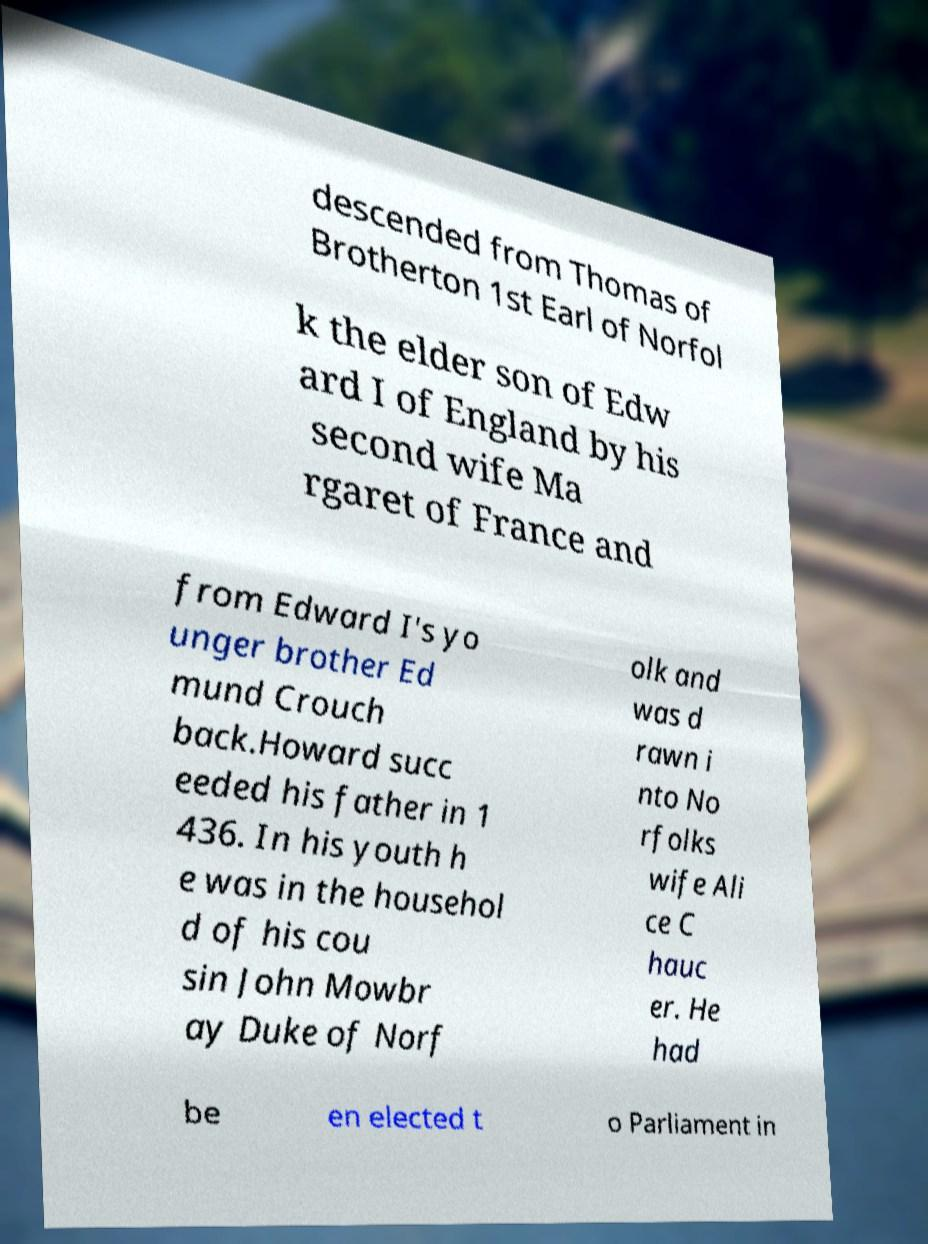Please read and relay the text visible in this image. What does it say? descended from Thomas of Brotherton 1st Earl of Norfol k the elder son of Edw ard I of England by his second wife Ma rgaret of France and from Edward I's yo unger brother Ed mund Crouch back.Howard succ eeded his father in 1 436. In his youth h e was in the househol d of his cou sin John Mowbr ay Duke of Norf olk and was d rawn i nto No rfolks wife Ali ce C hauc er. He had be en elected t o Parliament in 